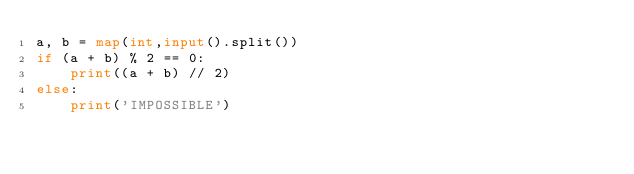Convert code to text. <code><loc_0><loc_0><loc_500><loc_500><_Python_>a, b = map(int,input().split())
if (a + b) % 2 == 0:
    print((a + b) // 2)
else:
    print('IMPOSSIBLE')</code> 